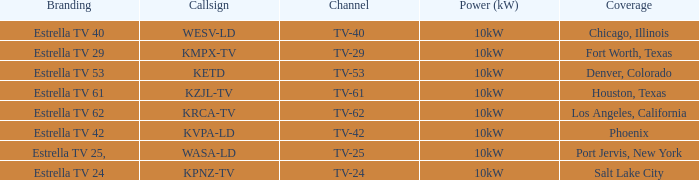State the branding identity for channel tv-6 Estrella TV 62. 